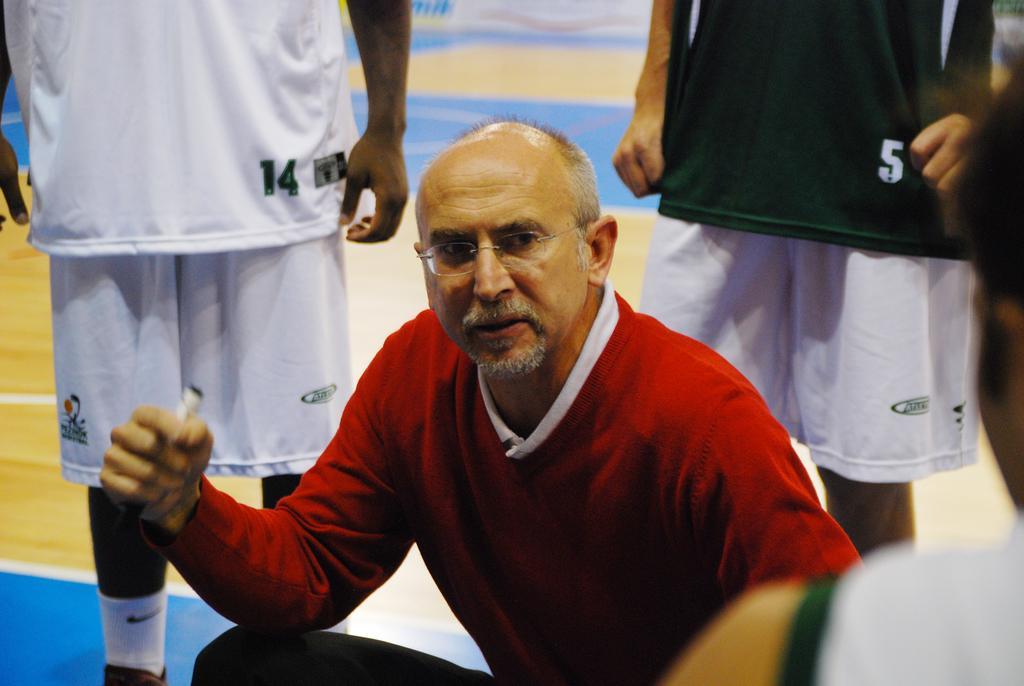Can you describe this image briefly? In this picture there is a man who is wearing spectacle, sweater, t-shirt and trouser. He is holding a white object in his hand. Beside him I can see some persons who are wearing t-shirt and shorts. They are standing on the basketball court. 